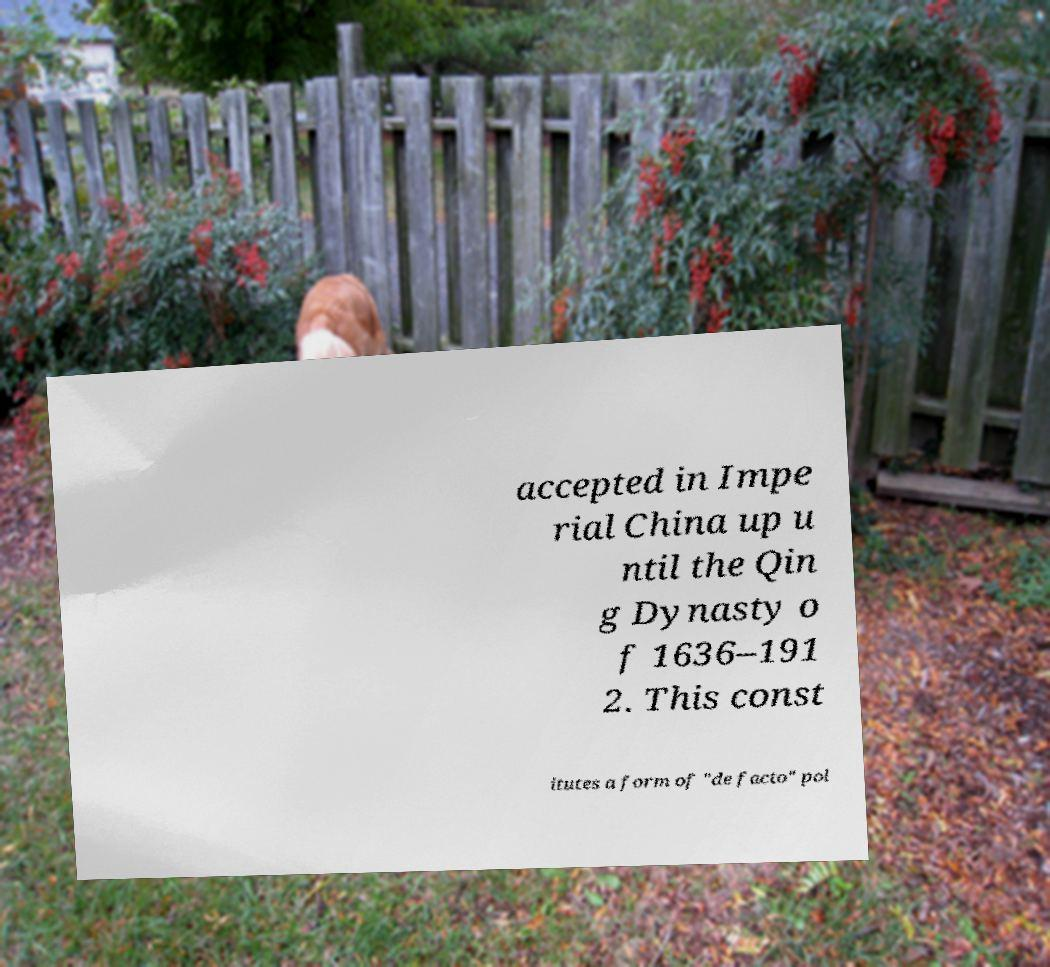Could you extract and type out the text from this image? accepted in Impe rial China up u ntil the Qin g Dynasty o f 1636–191 2. This const itutes a form of "de facto" pol 